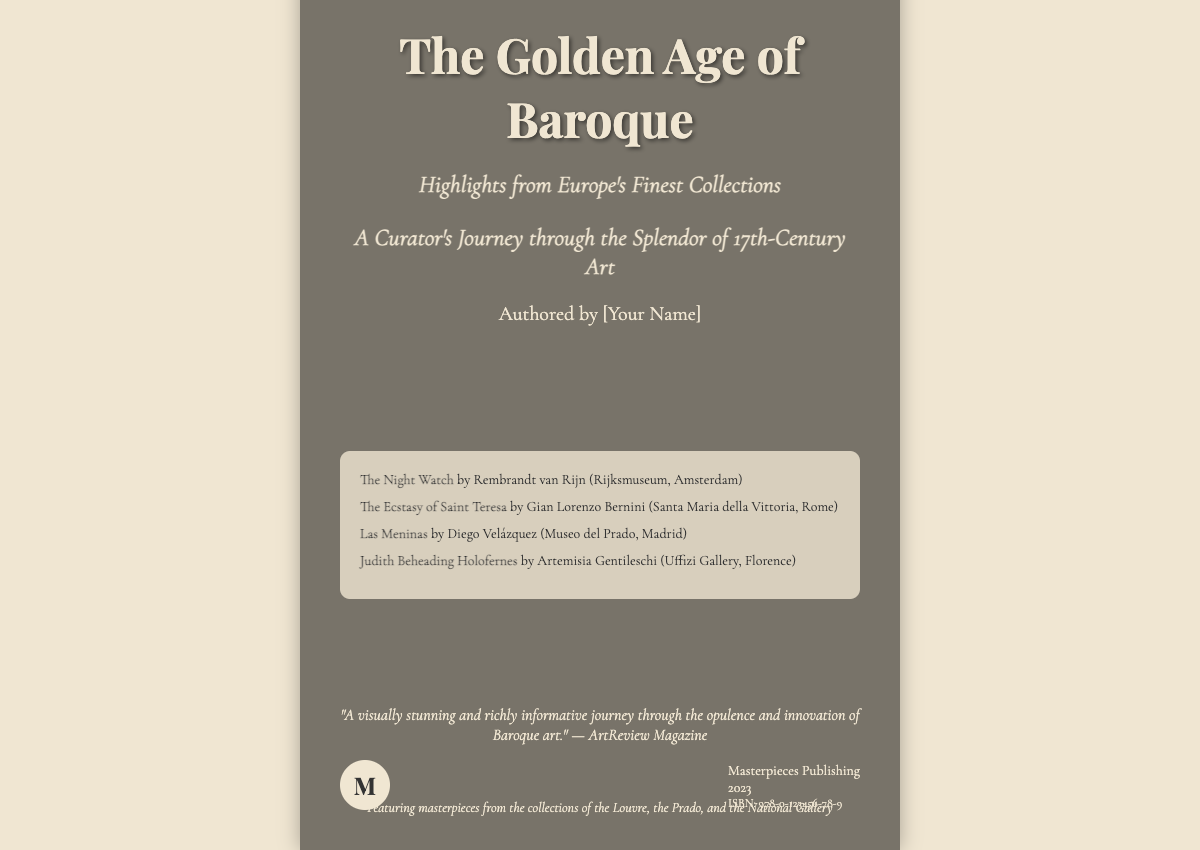What is the title of the book? The title of the book is prominently displayed at the top of the cover in large font.
Answer: The Golden Age of Baroque Who is the author? The author's name is indicated beneath the title on the cover.
Answer: [Your Name] What is the subtitle of the book? The subtitle is presented under the title and provides additional context about the book's content.
Answer: Highlights from Europe's Finest Collections Which artwork is featured first in the highlighted artworks section? The first artwork listed in the highlighted section is shown with the artist's name and collection.
Answer: The Night Watch Which museum houses "Las Meninas"? The document specifies the museum that contains this particular artwork, providing location context.
Answer: Museo del Prado What year was the book published? The publication year is noted in the publisher's section towards the bottom of the cover.
Answer: 2023 What is the ISBN of the book? The ISBN is typically provided in a smaller font near the publisher's information.
Answer: 978-0-123456-78-9 What is one of the endorsements for the book? An endorsement from a magazine about the book is presented as a quote on the cover.
Answer: "A visually stunning and richly informative journey through the opulence and innovation of Baroque art." What city is the Rijksmuseum located in? The location of the Rijksmuseum is implied in the description of the artwork by Rembrandt listed in the highlighted section.
Answer: Amsterdam 